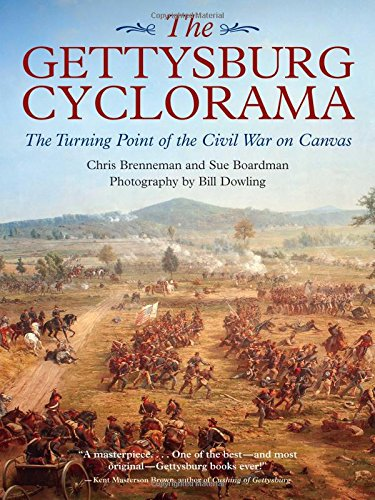What is the title of this book? The title of the book is 'The Gettysburg Cyclorama: The Turning Point of the Civil War on Canvas.' It explores the significant moment of the Gettysburg battle and presents it through a combination of narrative and vivid pictorial representations. 